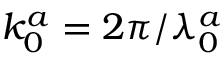Convert formula to latex. <formula><loc_0><loc_0><loc_500><loc_500>k _ { 0 } ^ { a } = 2 \pi / \lambda _ { 0 } ^ { a }</formula> 